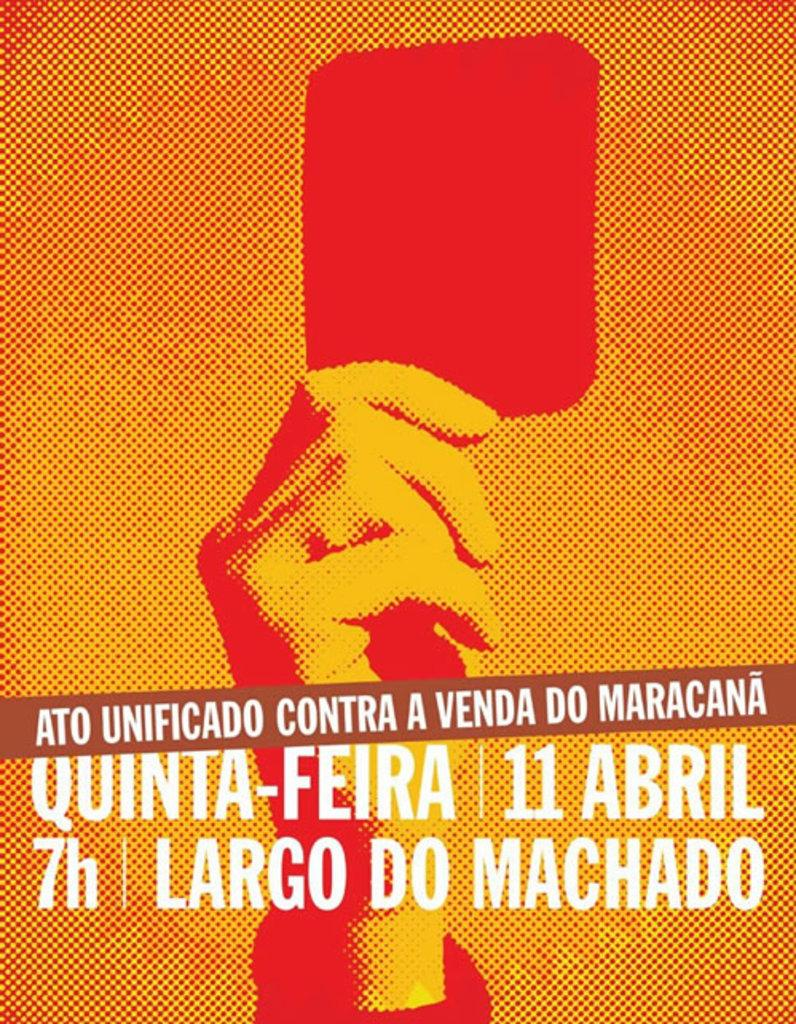<image>
Summarize the visual content of the image. an orange and red poster of a hand holding a square advertising an event for april 11 